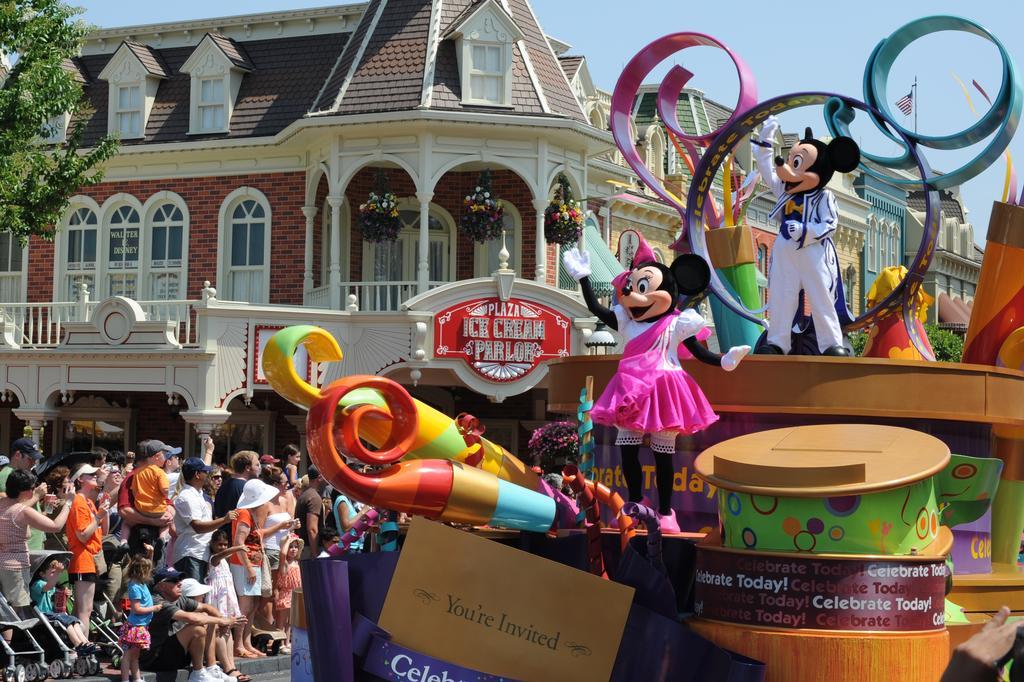How would you summarize this image in a sentence or two? In this image I can see the group of people with different color dresses. I can see few people are wearing the caps and few people are sitting on the wheel chairs. To the right there are many toys and boards which are colorful. In the background I can see the building with windows. I can also see the flowers hanged to the building. To the left I can see the tree. I can also see the sky in the back. 